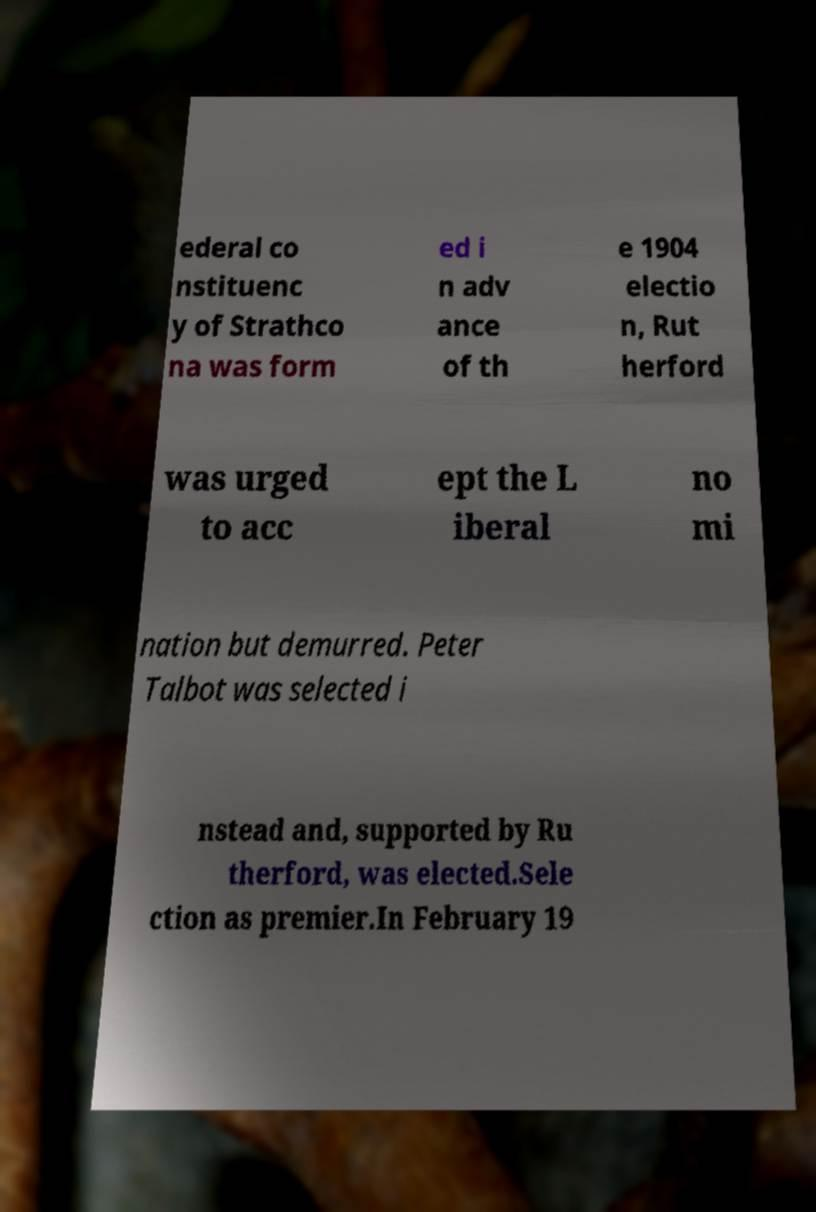Could you assist in decoding the text presented in this image and type it out clearly? ederal co nstituenc y of Strathco na was form ed i n adv ance of th e 1904 electio n, Rut herford was urged to acc ept the L iberal no mi nation but demurred. Peter Talbot was selected i nstead and, supported by Ru therford, was elected.Sele ction as premier.In February 19 